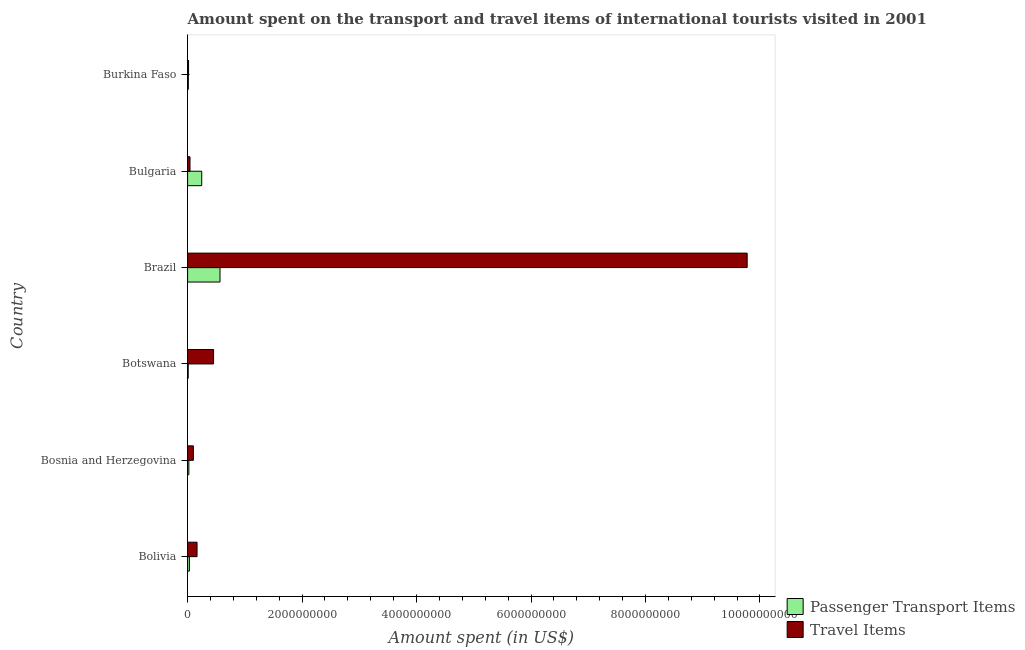How many different coloured bars are there?
Your answer should be very brief. 2. How many groups of bars are there?
Provide a short and direct response. 6. Are the number of bars per tick equal to the number of legend labels?
Make the answer very short. Yes. How many bars are there on the 4th tick from the top?
Offer a terse response. 2. How many bars are there on the 1st tick from the bottom?
Your response must be concise. 2. What is the label of the 6th group of bars from the top?
Keep it short and to the point. Bolivia. In how many cases, is the number of bars for a given country not equal to the number of legend labels?
Offer a very short reply. 0. What is the amount spent in travel items in Bulgaria?
Give a very brief answer. 4.20e+07. Across all countries, what is the maximum amount spent in travel items?
Ensure brevity in your answer.  9.78e+09. Across all countries, what is the minimum amount spent in travel items?
Offer a terse response. 1.70e+07. In which country was the amount spent on passenger transport items maximum?
Ensure brevity in your answer.  Brazil. In which country was the amount spent on passenger transport items minimum?
Make the answer very short. Botswana. What is the total amount spent in travel items in the graph?
Give a very brief answer. 1.06e+1. What is the difference between the amount spent in travel items in Bolivia and that in Botswana?
Offer a terse response. -2.89e+08. What is the difference between the amount spent in travel items in Bosnia and Herzegovina and the amount spent on passenger transport items in Burkina Faso?
Your response must be concise. 8.80e+07. What is the average amount spent in travel items per country?
Ensure brevity in your answer.  1.76e+09. What is the difference between the amount spent on passenger transport items and amount spent in travel items in Bosnia and Herzegovina?
Your answer should be very brief. -7.90e+07. What is the ratio of the amount spent on passenger transport items in Botswana to that in Burkina Faso?
Your response must be concise. 0.85. Is the amount spent in travel items in Botswana less than that in Brazil?
Ensure brevity in your answer.  Yes. Is the difference between the amount spent on passenger transport items in Brazil and Burkina Faso greater than the difference between the amount spent in travel items in Brazil and Burkina Faso?
Provide a short and direct response. No. What is the difference between the highest and the second highest amount spent on passenger transport items?
Make the answer very short. 3.19e+08. What is the difference between the highest and the lowest amount spent in travel items?
Your answer should be very brief. 9.76e+09. In how many countries, is the amount spent in travel items greater than the average amount spent in travel items taken over all countries?
Offer a terse response. 1. Is the sum of the amount spent on passenger transport items in Bosnia and Herzegovina and Brazil greater than the maximum amount spent in travel items across all countries?
Ensure brevity in your answer.  No. What does the 1st bar from the top in Bulgaria represents?
Your answer should be very brief. Travel Items. What does the 1st bar from the bottom in Burkina Faso represents?
Provide a succinct answer. Passenger Transport Items. How many bars are there?
Offer a terse response. 12. How many countries are there in the graph?
Provide a short and direct response. 6. What is the difference between two consecutive major ticks on the X-axis?
Your answer should be very brief. 2.00e+09. Are the values on the major ticks of X-axis written in scientific E-notation?
Your answer should be compact. No. Does the graph contain any zero values?
Your answer should be very brief. No. Does the graph contain grids?
Offer a terse response. No. Where does the legend appear in the graph?
Your response must be concise. Bottom right. How many legend labels are there?
Give a very brief answer. 2. How are the legend labels stacked?
Provide a short and direct response. Vertical. What is the title of the graph?
Provide a succinct answer. Amount spent on the transport and travel items of international tourists visited in 2001. What is the label or title of the X-axis?
Offer a very short reply. Amount spent (in US$). What is the Amount spent (in US$) of Passenger Transport Items in Bolivia?
Make the answer very short. 3.10e+07. What is the Amount spent (in US$) in Travel Items in Bolivia?
Offer a very short reply. 1.65e+08. What is the Amount spent (in US$) in Passenger Transport Items in Bosnia and Herzegovina?
Make the answer very short. 2.20e+07. What is the Amount spent (in US$) in Travel Items in Bosnia and Herzegovina?
Your answer should be very brief. 1.01e+08. What is the Amount spent (in US$) of Passenger Transport Items in Botswana?
Your answer should be very brief. 1.10e+07. What is the Amount spent (in US$) of Travel Items in Botswana?
Provide a succinct answer. 4.54e+08. What is the Amount spent (in US$) in Passenger Transport Items in Brazil?
Give a very brief answer. 5.66e+08. What is the Amount spent (in US$) of Travel Items in Brazil?
Provide a succinct answer. 9.78e+09. What is the Amount spent (in US$) in Passenger Transport Items in Bulgaria?
Keep it short and to the point. 2.47e+08. What is the Amount spent (in US$) in Travel Items in Bulgaria?
Provide a short and direct response. 4.20e+07. What is the Amount spent (in US$) of Passenger Transport Items in Burkina Faso?
Keep it short and to the point. 1.30e+07. What is the Amount spent (in US$) in Travel Items in Burkina Faso?
Give a very brief answer. 1.70e+07. Across all countries, what is the maximum Amount spent (in US$) in Passenger Transport Items?
Your answer should be compact. 5.66e+08. Across all countries, what is the maximum Amount spent (in US$) of Travel Items?
Offer a very short reply. 9.78e+09. Across all countries, what is the minimum Amount spent (in US$) in Passenger Transport Items?
Your response must be concise. 1.10e+07. Across all countries, what is the minimum Amount spent (in US$) in Travel Items?
Provide a succinct answer. 1.70e+07. What is the total Amount spent (in US$) of Passenger Transport Items in the graph?
Your response must be concise. 8.90e+08. What is the total Amount spent (in US$) in Travel Items in the graph?
Provide a short and direct response. 1.06e+1. What is the difference between the Amount spent (in US$) in Passenger Transport Items in Bolivia and that in Bosnia and Herzegovina?
Ensure brevity in your answer.  9.00e+06. What is the difference between the Amount spent (in US$) in Travel Items in Bolivia and that in Bosnia and Herzegovina?
Give a very brief answer. 6.40e+07. What is the difference between the Amount spent (in US$) of Travel Items in Bolivia and that in Botswana?
Your answer should be compact. -2.89e+08. What is the difference between the Amount spent (in US$) in Passenger Transport Items in Bolivia and that in Brazil?
Make the answer very short. -5.35e+08. What is the difference between the Amount spent (in US$) in Travel Items in Bolivia and that in Brazil?
Offer a terse response. -9.61e+09. What is the difference between the Amount spent (in US$) in Passenger Transport Items in Bolivia and that in Bulgaria?
Keep it short and to the point. -2.16e+08. What is the difference between the Amount spent (in US$) in Travel Items in Bolivia and that in Bulgaria?
Your response must be concise. 1.23e+08. What is the difference between the Amount spent (in US$) in Passenger Transport Items in Bolivia and that in Burkina Faso?
Give a very brief answer. 1.80e+07. What is the difference between the Amount spent (in US$) of Travel Items in Bolivia and that in Burkina Faso?
Ensure brevity in your answer.  1.48e+08. What is the difference between the Amount spent (in US$) in Passenger Transport Items in Bosnia and Herzegovina and that in Botswana?
Your response must be concise. 1.10e+07. What is the difference between the Amount spent (in US$) in Travel Items in Bosnia and Herzegovina and that in Botswana?
Ensure brevity in your answer.  -3.53e+08. What is the difference between the Amount spent (in US$) in Passenger Transport Items in Bosnia and Herzegovina and that in Brazil?
Give a very brief answer. -5.44e+08. What is the difference between the Amount spent (in US$) of Travel Items in Bosnia and Herzegovina and that in Brazil?
Give a very brief answer. -9.68e+09. What is the difference between the Amount spent (in US$) of Passenger Transport Items in Bosnia and Herzegovina and that in Bulgaria?
Your answer should be compact. -2.25e+08. What is the difference between the Amount spent (in US$) of Travel Items in Bosnia and Herzegovina and that in Bulgaria?
Offer a terse response. 5.90e+07. What is the difference between the Amount spent (in US$) of Passenger Transport Items in Bosnia and Herzegovina and that in Burkina Faso?
Offer a very short reply. 9.00e+06. What is the difference between the Amount spent (in US$) in Travel Items in Bosnia and Herzegovina and that in Burkina Faso?
Ensure brevity in your answer.  8.40e+07. What is the difference between the Amount spent (in US$) of Passenger Transport Items in Botswana and that in Brazil?
Make the answer very short. -5.55e+08. What is the difference between the Amount spent (in US$) of Travel Items in Botswana and that in Brazil?
Make the answer very short. -9.32e+09. What is the difference between the Amount spent (in US$) of Passenger Transport Items in Botswana and that in Bulgaria?
Your answer should be very brief. -2.36e+08. What is the difference between the Amount spent (in US$) of Travel Items in Botswana and that in Bulgaria?
Your response must be concise. 4.12e+08. What is the difference between the Amount spent (in US$) in Passenger Transport Items in Botswana and that in Burkina Faso?
Your answer should be compact. -2.00e+06. What is the difference between the Amount spent (in US$) in Travel Items in Botswana and that in Burkina Faso?
Your answer should be compact. 4.37e+08. What is the difference between the Amount spent (in US$) of Passenger Transport Items in Brazil and that in Bulgaria?
Offer a very short reply. 3.19e+08. What is the difference between the Amount spent (in US$) of Travel Items in Brazil and that in Bulgaria?
Make the answer very short. 9.73e+09. What is the difference between the Amount spent (in US$) of Passenger Transport Items in Brazil and that in Burkina Faso?
Provide a succinct answer. 5.53e+08. What is the difference between the Amount spent (in US$) in Travel Items in Brazil and that in Burkina Faso?
Provide a short and direct response. 9.76e+09. What is the difference between the Amount spent (in US$) in Passenger Transport Items in Bulgaria and that in Burkina Faso?
Your answer should be compact. 2.34e+08. What is the difference between the Amount spent (in US$) in Travel Items in Bulgaria and that in Burkina Faso?
Provide a succinct answer. 2.50e+07. What is the difference between the Amount spent (in US$) of Passenger Transport Items in Bolivia and the Amount spent (in US$) of Travel Items in Bosnia and Herzegovina?
Make the answer very short. -7.00e+07. What is the difference between the Amount spent (in US$) of Passenger Transport Items in Bolivia and the Amount spent (in US$) of Travel Items in Botswana?
Ensure brevity in your answer.  -4.23e+08. What is the difference between the Amount spent (in US$) of Passenger Transport Items in Bolivia and the Amount spent (in US$) of Travel Items in Brazil?
Ensure brevity in your answer.  -9.74e+09. What is the difference between the Amount spent (in US$) of Passenger Transport Items in Bolivia and the Amount spent (in US$) of Travel Items in Bulgaria?
Your response must be concise. -1.10e+07. What is the difference between the Amount spent (in US$) in Passenger Transport Items in Bolivia and the Amount spent (in US$) in Travel Items in Burkina Faso?
Provide a short and direct response. 1.40e+07. What is the difference between the Amount spent (in US$) of Passenger Transport Items in Bosnia and Herzegovina and the Amount spent (in US$) of Travel Items in Botswana?
Offer a very short reply. -4.32e+08. What is the difference between the Amount spent (in US$) of Passenger Transport Items in Bosnia and Herzegovina and the Amount spent (in US$) of Travel Items in Brazil?
Your response must be concise. -9.75e+09. What is the difference between the Amount spent (in US$) of Passenger Transport Items in Bosnia and Herzegovina and the Amount spent (in US$) of Travel Items in Bulgaria?
Give a very brief answer. -2.00e+07. What is the difference between the Amount spent (in US$) of Passenger Transport Items in Botswana and the Amount spent (in US$) of Travel Items in Brazil?
Offer a very short reply. -9.76e+09. What is the difference between the Amount spent (in US$) of Passenger Transport Items in Botswana and the Amount spent (in US$) of Travel Items in Bulgaria?
Give a very brief answer. -3.10e+07. What is the difference between the Amount spent (in US$) in Passenger Transport Items in Botswana and the Amount spent (in US$) in Travel Items in Burkina Faso?
Provide a succinct answer. -6.00e+06. What is the difference between the Amount spent (in US$) of Passenger Transport Items in Brazil and the Amount spent (in US$) of Travel Items in Bulgaria?
Provide a short and direct response. 5.24e+08. What is the difference between the Amount spent (in US$) of Passenger Transport Items in Brazil and the Amount spent (in US$) of Travel Items in Burkina Faso?
Make the answer very short. 5.49e+08. What is the difference between the Amount spent (in US$) of Passenger Transport Items in Bulgaria and the Amount spent (in US$) of Travel Items in Burkina Faso?
Give a very brief answer. 2.30e+08. What is the average Amount spent (in US$) in Passenger Transport Items per country?
Offer a terse response. 1.48e+08. What is the average Amount spent (in US$) in Travel Items per country?
Give a very brief answer. 1.76e+09. What is the difference between the Amount spent (in US$) in Passenger Transport Items and Amount spent (in US$) in Travel Items in Bolivia?
Keep it short and to the point. -1.34e+08. What is the difference between the Amount spent (in US$) of Passenger Transport Items and Amount spent (in US$) of Travel Items in Bosnia and Herzegovina?
Make the answer very short. -7.90e+07. What is the difference between the Amount spent (in US$) in Passenger Transport Items and Amount spent (in US$) in Travel Items in Botswana?
Your response must be concise. -4.43e+08. What is the difference between the Amount spent (in US$) of Passenger Transport Items and Amount spent (in US$) of Travel Items in Brazil?
Provide a short and direct response. -9.21e+09. What is the difference between the Amount spent (in US$) in Passenger Transport Items and Amount spent (in US$) in Travel Items in Bulgaria?
Give a very brief answer. 2.05e+08. What is the ratio of the Amount spent (in US$) of Passenger Transport Items in Bolivia to that in Bosnia and Herzegovina?
Ensure brevity in your answer.  1.41. What is the ratio of the Amount spent (in US$) of Travel Items in Bolivia to that in Bosnia and Herzegovina?
Make the answer very short. 1.63. What is the ratio of the Amount spent (in US$) of Passenger Transport Items in Bolivia to that in Botswana?
Your answer should be very brief. 2.82. What is the ratio of the Amount spent (in US$) of Travel Items in Bolivia to that in Botswana?
Keep it short and to the point. 0.36. What is the ratio of the Amount spent (in US$) of Passenger Transport Items in Bolivia to that in Brazil?
Offer a terse response. 0.05. What is the ratio of the Amount spent (in US$) in Travel Items in Bolivia to that in Brazil?
Make the answer very short. 0.02. What is the ratio of the Amount spent (in US$) in Passenger Transport Items in Bolivia to that in Bulgaria?
Give a very brief answer. 0.13. What is the ratio of the Amount spent (in US$) in Travel Items in Bolivia to that in Bulgaria?
Keep it short and to the point. 3.93. What is the ratio of the Amount spent (in US$) of Passenger Transport Items in Bolivia to that in Burkina Faso?
Your answer should be very brief. 2.38. What is the ratio of the Amount spent (in US$) in Travel Items in Bolivia to that in Burkina Faso?
Your answer should be compact. 9.71. What is the ratio of the Amount spent (in US$) of Travel Items in Bosnia and Herzegovina to that in Botswana?
Ensure brevity in your answer.  0.22. What is the ratio of the Amount spent (in US$) of Passenger Transport Items in Bosnia and Herzegovina to that in Brazil?
Ensure brevity in your answer.  0.04. What is the ratio of the Amount spent (in US$) of Travel Items in Bosnia and Herzegovina to that in Brazil?
Provide a succinct answer. 0.01. What is the ratio of the Amount spent (in US$) of Passenger Transport Items in Bosnia and Herzegovina to that in Bulgaria?
Your answer should be compact. 0.09. What is the ratio of the Amount spent (in US$) in Travel Items in Bosnia and Herzegovina to that in Bulgaria?
Make the answer very short. 2.4. What is the ratio of the Amount spent (in US$) of Passenger Transport Items in Bosnia and Herzegovina to that in Burkina Faso?
Offer a very short reply. 1.69. What is the ratio of the Amount spent (in US$) in Travel Items in Bosnia and Herzegovina to that in Burkina Faso?
Your answer should be very brief. 5.94. What is the ratio of the Amount spent (in US$) in Passenger Transport Items in Botswana to that in Brazil?
Offer a terse response. 0.02. What is the ratio of the Amount spent (in US$) in Travel Items in Botswana to that in Brazil?
Your answer should be very brief. 0.05. What is the ratio of the Amount spent (in US$) in Passenger Transport Items in Botswana to that in Bulgaria?
Ensure brevity in your answer.  0.04. What is the ratio of the Amount spent (in US$) of Travel Items in Botswana to that in Bulgaria?
Your answer should be compact. 10.81. What is the ratio of the Amount spent (in US$) in Passenger Transport Items in Botswana to that in Burkina Faso?
Keep it short and to the point. 0.85. What is the ratio of the Amount spent (in US$) of Travel Items in Botswana to that in Burkina Faso?
Ensure brevity in your answer.  26.71. What is the ratio of the Amount spent (in US$) in Passenger Transport Items in Brazil to that in Bulgaria?
Offer a very short reply. 2.29. What is the ratio of the Amount spent (in US$) of Travel Items in Brazil to that in Bulgaria?
Keep it short and to the point. 232.76. What is the ratio of the Amount spent (in US$) in Passenger Transport Items in Brazil to that in Burkina Faso?
Your answer should be compact. 43.54. What is the ratio of the Amount spent (in US$) in Travel Items in Brazil to that in Burkina Faso?
Make the answer very short. 575.06. What is the ratio of the Amount spent (in US$) of Passenger Transport Items in Bulgaria to that in Burkina Faso?
Give a very brief answer. 19. What is the ratio of the Amount spent (in US$) in Travel Items in Bulgaria to that in Burkina Faso?
Keep it short and to the point. 2.47. What is the difference between the highest and the second highest Amount spent (in US$) in Passenger Transport Items?
Give a very brief answer. 3.19e+08. What is the difference between the highest and the second highest Amount spent (in US$) of Travel Items?
Give a very brief answer. 9.32e+09. What is the difference between the highest and the lowest Amount spent (in US$) in Passenger Transport Items?
Your answer should be very brief. 5.55e+08. What is the difference between the highest and the lowest Amount spent (in US$) of Travel Items?
Your response must be concise. 9.76e+09. 